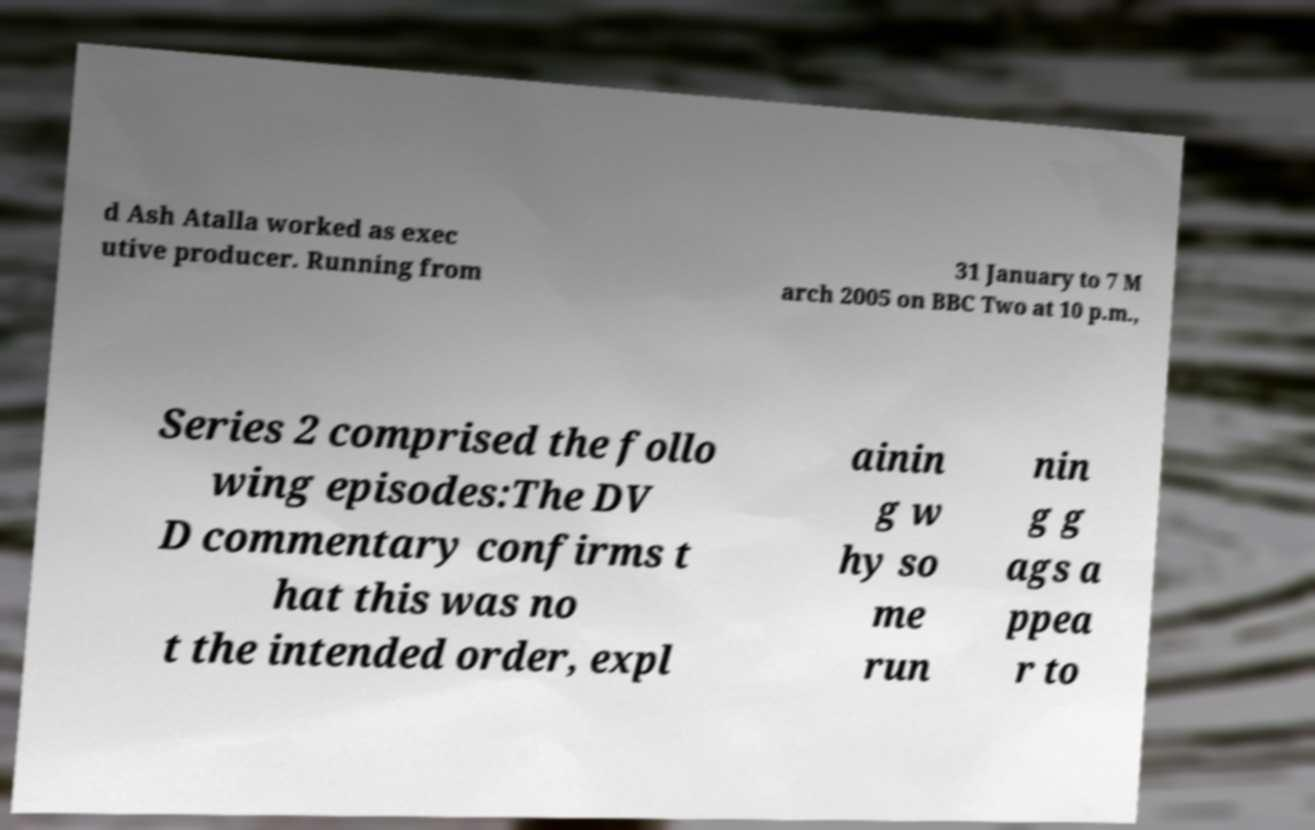For documentation purposes, I need the text within this image transcribed. Could you provide that? d Ash Atalla worked as exec utive producer. Running from 31 January to 7 M arch 2005 on BBC Two at 10 p.m., Series 2 comprised the follo wing episodes:The DV D commentary confirms t hat this was no t the intended order, expl ainin g w hy so me run nin g g ags a ppea r to 